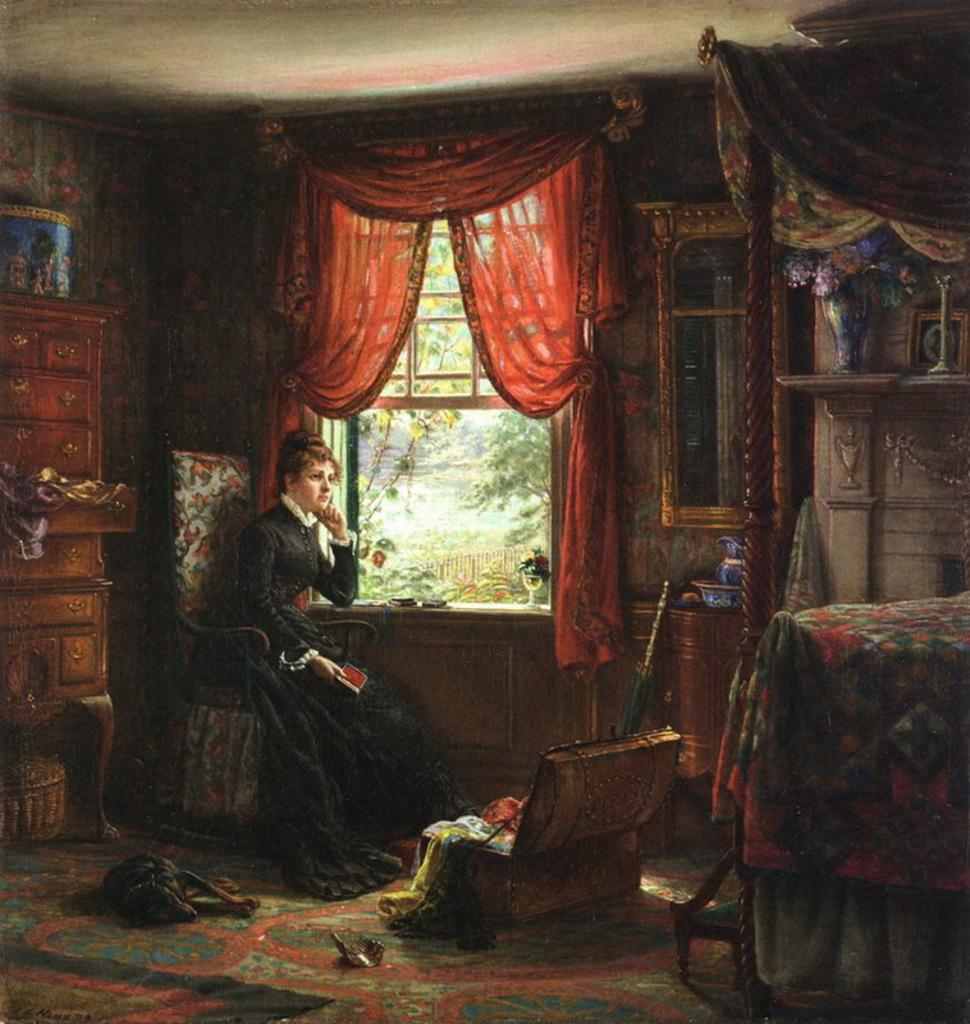In one or two sentences, can you explain what this image depicts? This is a painting. On the left side there is a cupboard. Below the cupboard there is a basket. Near to that there is a chair. On that a lady is sitting. Near to the lady there is a window with curtains. On the right side there is a cot with bed sheet. In the back there is a vase with flowers. On the floor there is a dog and a box with some clothes. 